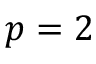Convert formula to latex. <formula><loc_0><loc_0><loc_500><loc_500>p = 2</formula> 